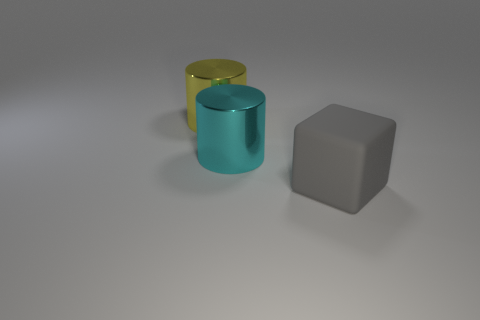There is a cyan metal thing that is the same shape as the large yellow object; what is its size? The cyan object, which shares its cylindrical shape with the larger yellow one, appears to be medium-sized in comparison to the yellow cylinder and grey cube present in the image. 